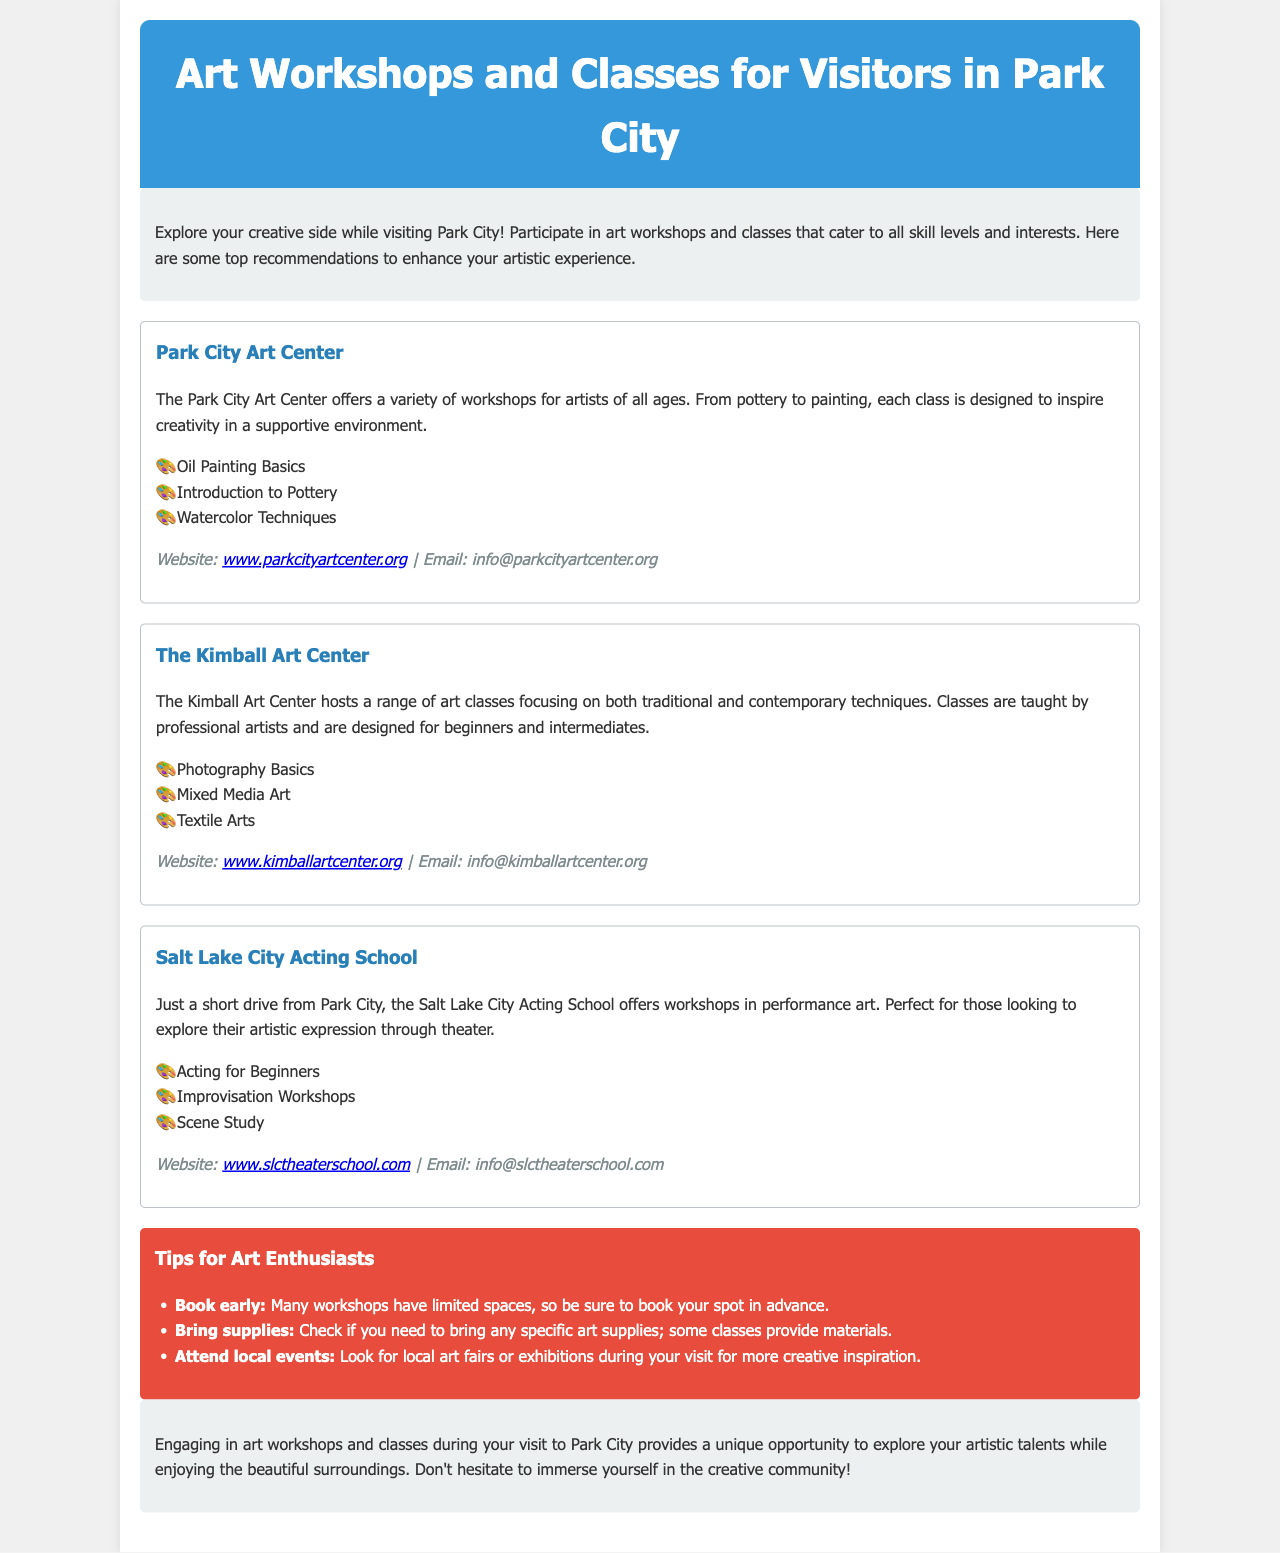What is the name of the first workshop mentioned? The first workshop in the document is listed as "Park City Art Center."
Answer: Park City Art Center How many classes does the Kimball Art Center offer? The Kimball Art Center offers three classes: Photography Basics, Mixed Media Art, and Textile Arts.
Answer: 3 What type of arts does the Salt Lake City Acting School focus on? The Salt Lake City Acting School focuses on performance art.
Answer: Performance art What should participants check regarding art supplies? Participants should check if they need to bring any specific art supplies, as some classes provide materials.
Answer: Bring specific supplies Which workshop offers pottery classes? The workshop that offers pottery classes is the Park City Art Center.
Answer: Park City Art Center What is a recommended action for early bookings? The document states that many workshops have limited spaces, so booking your spot in advance is recommended.
Answer: Book early How can visitors find more creative inspiration during their visit? Visitors can attend local art fairs or exhibitions.
Answer: Attend local events What is the main purpose of the brochure? The brochure encourages exploration of art workshops and classes while visiting Park City.
Answer: Explore artistic talents 